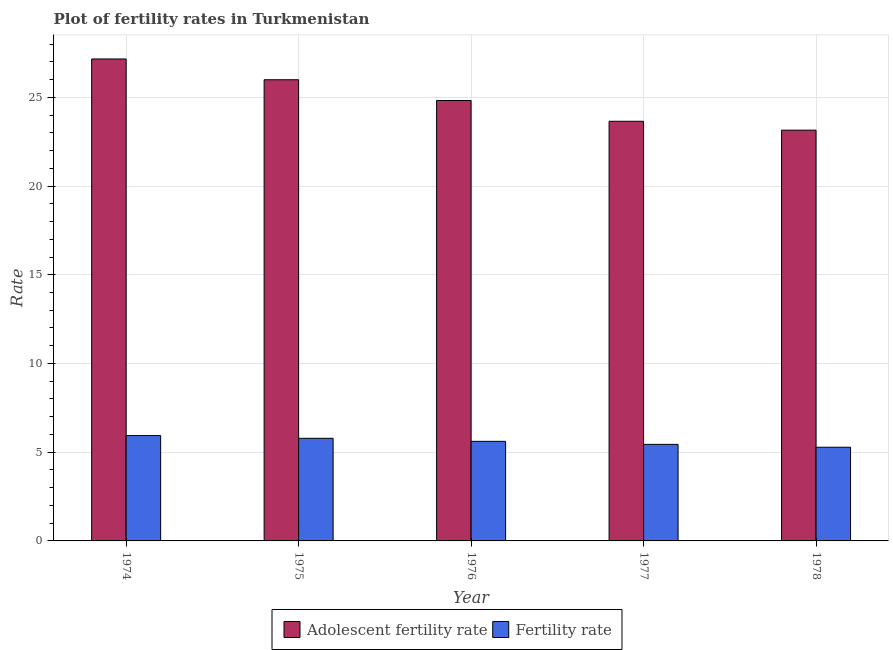How many bars are there on the 1st tick from the left?
Make the answer very short. 2. What is the label of the 1st group of bars from the left?
Ensure brevity in your answer.  1974. In how many cases, is the number of bars for a given year not equal to the number of legend labels?
Make the answer very short. 0. What is the fertility rate in 1974?
Give a very brief answer. 5.94. Across all years, what is the maximum adolescent fertility rate?
Your answer should be very brief. 27.16. Across all years, what is the minimum fertility rate?
Provide a short and direct response. 5.28. In which year was the fertility rate maximum?
Offer a terse response. 1974. In which year was the fertility rate minimum?
Make the answer very short. 1978. What is the total fertility rate in the graph?
Ensure brevity in your answer.  28.05. What is the difference between the adolescent fertility rate in 1975 and that in 1977?
Your response must be concise. 2.34. What is the difference between the fertility rate in 1976 and the adolescent fertility rate in 1974?
Your response must be concise. -0.33. What is the average adolescent fertility rate per year?
Give a very brief answer. 24.95. What is the ratio of the adolescent fertility rate in 1974 to that in 1978?
Offer a very short reply. 1.17. What is the difference between the highest and the second highest adolescent fertility rate?
Make the answer very short. 1.17. What is the difference between the highest and the lowest fertility rate?
Your answer should be compact. 0.66. What does the 2nd bar from the left in 1976 represents?
Ensure brevity in your answer.  Fertility rate. What does the 2nd bar from the right in 1976 represents?
Your answer should be very brief. Adolescent fertility rate. How many years are there in the graph?
Ensure brevity in your answer.  5. What is the difference between two consecutive major ticks on the Y-axis?
Your answer should be compact. 5. Are the values on the major ticks of Y-axis written in scientific E-notation?
Your answer should be very brief. No. Does the graph contain grids?
Keep it short and to the point. Yes. Where does the legend appear in the graph?
Provide a succinct answer. Bottom center. What is the title of the graph?
Your response must be concise. Plot of fertility rates in Turkmenistan. What is the label or title of the Y-axis?
Your answer should be very brief. Rate. What is the Rate of Adolescent fertility rate in 1974?
Provide a succinct answer. 27.16. What is the Rate in Fertility rate in 1974?
Provide a succinct answer. 5.94. What is the Rate of Adolescent fertility rate in 1975?
Your answer should be very brief. 25.99. What is the Rate of Fertility rate in 1975?
Your response must be concise. 5.78. What is the Rate of Adolescent fertility rate in 1976?
Keep it short and to the point. 24.82. What is the Rate of Fertility rate in 1976?
Your answer should be very brief. 5.61. What is the Rate in Adolescent fertility rate in 1977?
Your response must be concise. 23.65. What is the Rate in Fertility rate in 1977?
Offer a very short reply. 5.44. What is the Rate in Adolescent fertility rate in 1978?
Your response must be concise. 23.15. What is the Rate of Fertility rate in 1978?
Provide a succinct answer. 5.28. Across all years, what is the maximum Rate in Adolescent fertility rate?
Offer a very short reply. 27.16. Across all years, what is the maximum Rate in Fertility rate?
Give a very brief answer. 5.94. Across all years, what is the minimum Rate in Adolescent fertility rate?
Offer a very short reply. 23.15. Across all years, what is the minimum Rate of Fertility rate?
Provide a succinct answer. 5.28. What is the total Rate of Adolescent fertility rate in the graph?
Keep it short and to the point. 124.77. What is the total Rate in Fertility rate in the graph?
Your answer should be very brief. 28.05. What is the difference between the Rate in Adolescent fertility rate in 1974 and that in 1975?
Your answer should be very brief. 1.17. What is the difference between the Rate of Fertility rate in 1974 and that in 1975?
Give a very brief answer. 0.16. What is the difference between the Rate in Adolescent fertility rate in 1974 and that in 1976?
Your answer should be very brief. 2.34. What is the difference between the Rate in Fertility rate in 1974 and that in 1976?
Your response must be concise. 0.33. What is the difference between the Rate of Adolescent fertility rate in 1974 and that in 1977?
Offer a very short reply. 3.51. What is the difference between the Rate in Fertility rate in 1974 and that in 1977?
Your answer should be compact. 0.5. What is the difference between the Rate of Adolescent fertility rate in 1974 and that in 1978?
Offer a very short reply. 4.01. What is the difference between the Rate in Fertility rate in 1974 and that in 1978?
Make the answer very short. 0.66. What is the difference between the Rate in Adolescent fertility rate in 1975 and that in 1976?
Provide a short and direct response. 1.17. What is the difference between the Rate of Fertility rate in 1975 and that in 1976?
Ensure brevity in your answer.  0.17. What is the difference between the Rate in Adolescent fertility rate in 1975 and that in 1977?
Make the answer very short. 2.34. What is the difference between the Rate of Fertility rate in 1975 and that in 1977?
Ensure brevity in your answer.  0.34. What is the difference between the Rate of Adolescent fertility rate in 1975 and that in 1978?
Your answer should be compact. 2.84. What is the difference between the Rate of Fertility rate in 1975 and that in 1978?
Provide a short and direct response. 0.5. What is the difference between the Rate of Adolescent fertility rate in 1976 and that in 1977?
Make the answer very short. 1.17. What is the difference between the Rate in Fertility rate in 1976 and that in 1977?
Offer a terse response. 0.17. What is the difference between the Rate of Adolescent fertility rate in 1976 and that in 1978?
Provide a succinct answer. 1.67. What is the difference between the Rate of Fertility rate in 1976 and that in 1978?
Keep it short and to the point. 0.33. What is the difference between the Rate in Adolescent fertility rate in 1977 and that in 1978?
Offer a terse response. 0.5. What is the difference between the Rate in Fertility rate in 1977 and that in 1978?
Keep it short and to the point. 0.16. What is the difference between the Rate in Adolescent fertility rate in 1974 and the Rate in Fertility rate in 1975?
Give a very brief answer. 21.38. What is the difference between the Rate in Adolescent fertility rate in 1974 and the Rate in Fertility rate in 1976?
Offer a very short reply. 21.55. What is the difference between the Rate in Adolescent fertility rate in 1974 and the Rate in Fertility rate in 1977?
Ensure brevity in your answer.  21.72. What is the difference between the Rate in Adolescent fertility rate in 1974 and the Rate in Fertility rate in 1978?
Provide a succinct answer. 21.88. What is the difference between the Rate of Adolescent fertility rate in 1975 and the Rate of Fertility rate in 1976?
Your answer should be very brief. 20.38. What is the difference between the Rate of Adolescent fertility rate in 1975 and the Rate of Fertility rate in 1977?
Give a very brief answer. 20.55. What is the difference between the Rate of Adolescent fertility rate in 1975 and the Rate of Fertility rate in 1978?
Provide a short and direct response. 20.71. What is the difference between the Rate in Adolescent fertility rate in 1976 and the Rate in Fertility rate in 1977?
Offer a very short reply. 19.38. What is the difference between the Rate of Adolescent fertility rate in 1976 and the Rate of Fertility rate in 1978?
Your response must be concise. 19.54. What is the difference between the Rate of Adolescent fertility rate in 1977 and the Rate of Fertility rate in 1978?
Keep it short and to the point. 18.37. What is the average Rate in Adolescent fertility rate per year?
Make the answer very short. 24.95. What is the average Rate in Fertility rate per year?
Ensure brevity in your answer.  5.61. In the year 1974, what is the difference between the Rate in Adolescent fertility rate and Rate in Fertility rate?
Make the answer very short. 21.22. In the year 1975, what is the difference between the Rate in Adolescent fertility rate and Rate in Fertility rate?
Make the answer very short. 20.21. In the year 1976, what is the difference between the Rate of Adolescent fertility rate and Rate of Fertility rate?
Ensure brevity in your answer.  19.21. In the year 1977, what is the difference between the Rate in Adolescent fertility rate and Rate in Fertility rate?
Ensure brevity in your answer.  18.21. In the year 1978, what is the difference between the Rate of Adolescent fertility rate and Rate of Fertility rate?
Your response must be concise. 17.87. What is the ratio of the Rate of Adolescent fertility rate in 1974 to that in 1975?
Your answer should be very brief. 1.04. What is the ratio of the Rate of Adolescent fertility rate in 1974 to that in 1976?
Offer a very short reply. 1.09. What is the ratio of the Rate in Fertility rate in 1974 to that in 1976?
Keep it short and to the point. 1.06. What is the ratio of the Rate in Adolescent fertility rate in 1974 to that in 1977?
Provide a short and direct response. 1.15. What is the ratio of the Rate of Fertility rate in 1974 to that in 1977?
Your response must be concise. 1.09. What is the ratio of the Rate in Adolescent fertility rate in 1974 to that in 1978?
Keep it short and to the point. 1.17. What is the ratio of the Rate in Fertility rate in 1974 to that in 1978?
Keep it short and to the point. 1.12. What is the ratio of the Rate in Adolescent fertility rate in 1975 to that in 1976?
Give a very brief answer. 1.05. What is the ratio of the Rate in Fertility rate in 1975 to that in 1976?
Offer a very short reply. 1.03. What is the ratio of the Rate in Adolescent fertility rate in 1975 to that in 1977?
Your answer should be compact. 1.1. What is the ratio of the Rate of Fertility rate in 1975 to that in 1977?
Keep it short and to the point. 1.06. What is the ratio of the Rate in Adolescent fertility rate in 1975 to that in 1978?
Ensure brevity in your answer.  1.12. What is the ratio of the Rate in Fertility rate in 1975 to that in 1978?
Your answer should be compact. 1.1. What is the ratio of the Rate of Adolescent fertility rate in 1976 to that in 1977?
Offer a terse response. 1.05. What is the ratio of the Rate in Fertility rate in 1976 to that in 1977?
Offer a very short reply. 1.03. What is the ratio of the Rate in Adolescent fertility rate in 1976 to that in 1978?
Provide a succinct answer. 1.07. What is the ratio of the Rate in Fertility rate in 1976 to that in 1978?
Provide a succinct answer. 1.06. What is the ratio of the Rate in Adolescent fertility rate in 1977 to that in 1978?
Your answer should be compact. 1.02. What is the ratio of the Rate of Fertility rate in 1977 to that in 1978?
Ensure brevity in your answer.  1.03. What is the difference between the highest and the second highest Rate of Adolescent fertility rate?
Your answer should be very brief. 1.17. What is the difference between the highest and the second highest Rate of Fertility rate?
Your response must be concise. 0.16. What is the difference between the highest and the lowest Rate of Adolescent fertility rate?
Provide a short and direct response. 4.01. What is the difference between the highest and the lowest Rate of Fertility rate?
Give a very brief answer. 0.66. 